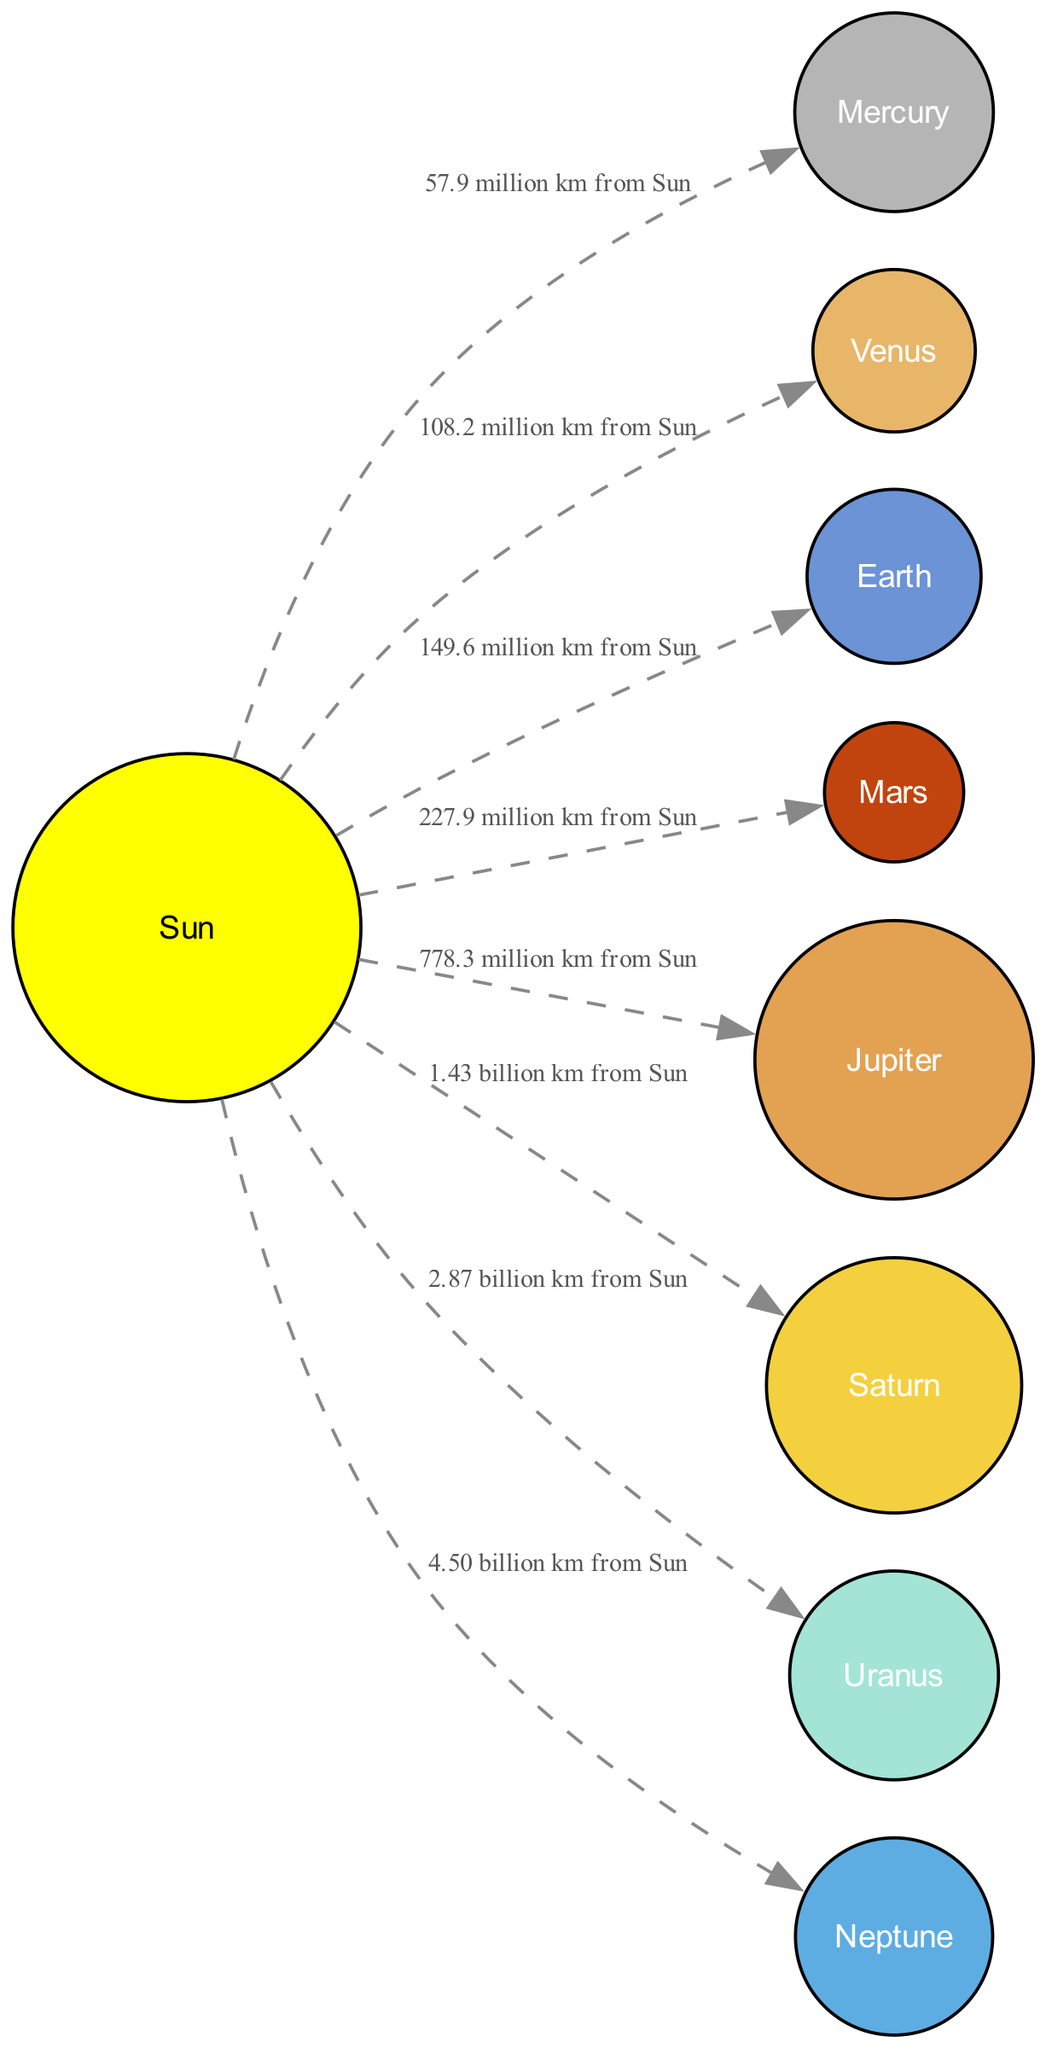What is the distance from the Sun to Jupiter? The diagram indicates that the distance from the Sun to Jupiter is labeled as "778.3 million km from Sun." This is a direct reference in the connections section of the diagram.
Answer: 778.3 million km Which planet is known as the Red Planet? The diagram lists Mars and includes the detail "often called the Red Planet due to its reddish appearance," clearly identifying it as the planet in question.
Answer: Mars What celestial body is at the center of the Solar System? The diagram shows the Sun as the central body with the label "The central star of the Solar System," confirming its position and role in the system.
Answer: Sun How many planets are there in the diagram? The diagram consists of nine primary elements (including the Sun) categorized as planets and a central body. Counting all the planets (Mercury, Venus, Earth, Mars, Jupiter, Saturn, Uranus, Neptune), we find a total of eight planets.
Answer: 8 What planet is furthest from the Sun? The diagram identifies Neptune as the furthest planet from the Sun, as it is the last planet mentioned under the elements and clearly states its position as "the eighth and farthest known planet from the Sun."
Answer: Neptune Which planet has the largest size in the Solar System? The diagram specifies Jupiter as "the largest planet in the Solar System," thereby establishing its size as the largest among the listed planets.
Answer: Jupiter At what distance is Saturn located from the Sun? The diagram indicates that Saturn is "1.43 billion km from Sun," providing a straightforward answer based on the connections section.
Answer: 1.43 billion km How many kilometers away is Earth from the Sun? The distance for Earth in the diagram is stated as "149.6 million km from Sun," clearly giving a specific measurement.
Answer: 149.6 million km What type of path do planets follow around the Sun? The diagram describes the path as "the elliptical path in which a planet revolves around the Sun," indicating the nature of the orbits that describe the planets' routes.
Answer: Elliptical path 